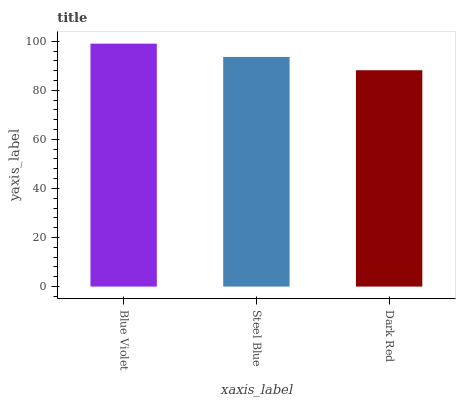Is Dark Red the minimum?
Answer yes or no. Yes. Is Blue Violet the maximum?
Answer yes or no. Yes. Is Steel Blue the minimum?
Answer yes or no. No. Is Steel Blue the maximum?
Answer yes or no. No. Is Blue Violet greater than Steel Blue?
Answer yes or no. Yes. Is Steel Blue less than Blue Violet?
Answer yes or no. Yes. Is Steel Blue greater than Blue Violet?
Answer yes or no. No. Is Blue Violet less than Steel Blue?
Answer yes or no. No. Is Steel Blue the high median?
Answer yes or no. Yes. Is Steel Blue the low median?
Answer yes or no. Yes. Is Blue Violet the high median?
Answer yes or no. No. Is Blue Violet the low median?
Answer yes or no. No. 